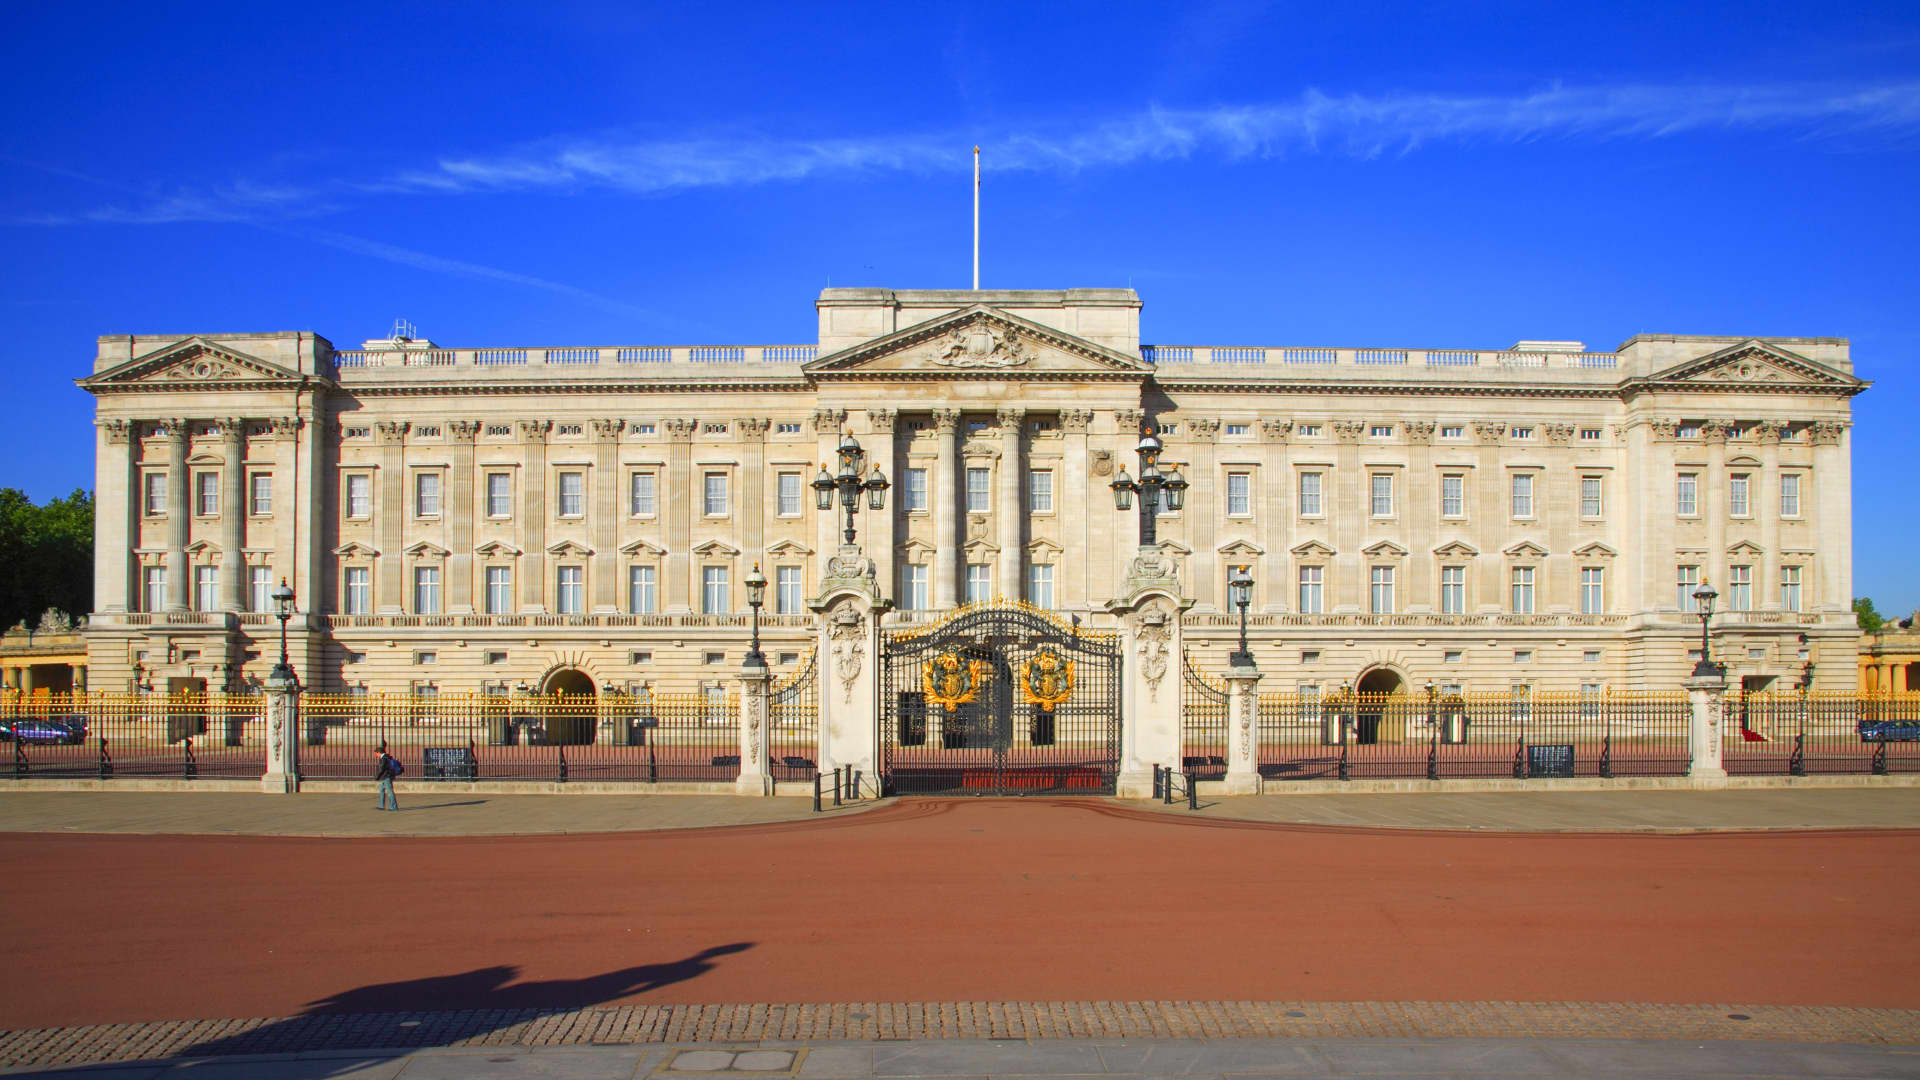Can you describe the significance of the statue in front of the palace? The statue in front of Buckingham Palace is the Victoria Memorial, an impressive monument dedicated to Queen Victoria, who reigned over the United Kingdom from 1837 to 1901. The memorial consists of a central part with a golden figure of 'Victory' standing triumphantly at the top, celebrating the successes of the British Empire. The surrounding statues represent concepts such as Truth, Justice, and Motherhood, symbolizing the values and ideals of Victoria’s reign. The placement of the memorial right in front of the palace emphasizes its importance and embodies the royal heritage of the British monarchy. What is the historical background of Buckingham Palace? Buckingham Palace has a rich history dating back to the early 18th century. Originally known as Buckingham House, it was built in 1703 for the Duke of Buckingham. In 1761, King George III acquired it for Queen Charlotte, and it became known as the Queen’s House. Significant expansions and changes were made in the 19th century under the direction of architects like John Nash and Edward Blore, transforming it into the grand palace we see today. It officially became the royal residence of the British monarch with Queen Victoria’s accession to the throne in 1837. Since then, it has served as the administrative headquarters of the monarchy, hosting state occasions, royal banquets, and other official functions. 